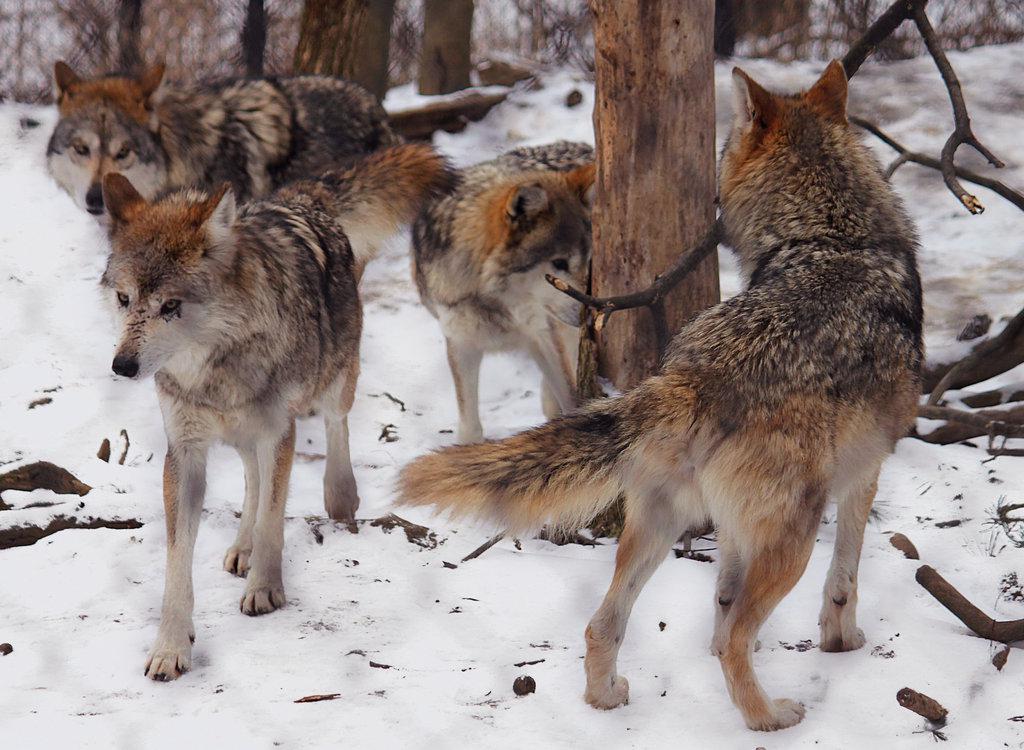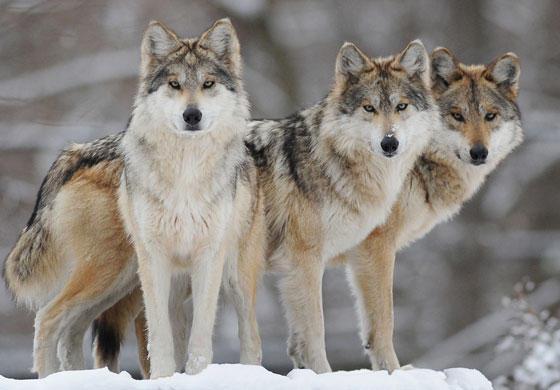The first image is the image on the left, the second image is the image on the right. Considering the images on both sides, is "An image features exactly three wolves, which look toward the camera." valid? Answer yes or no. Yes. The first image is the image on the left, the second image is the image on the right. Considering the images on both sides, is "The right image contains two or fewer wolves." valid? Answer yes or no. No. 